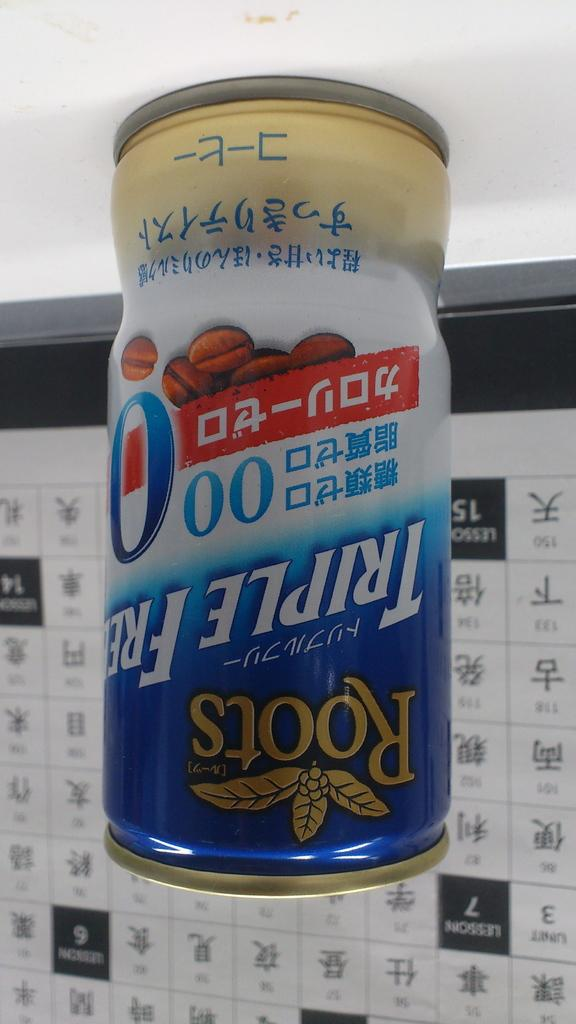<image>
Share a concise interpretation of the image provided. A can of Roots Tripple Free is on a flat surface, in front of a calendar that is hanging on the wall. 